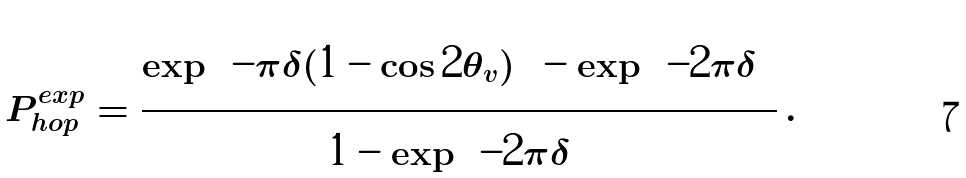Convert formula to latex. <formula><loc_0><loc_0><loc_500><loc_500>P ^ { e x p } _ { h o p } = \frac { \exp \left ( - \pi \delta ( 1 - \cos { 2 \theta _ { v } } ) \right ) - \exp \left ( - 2 \pi \delta \right ) } { 1 - \exp \left ( - 2 \pi \delta \right ) } \, .</formula> 